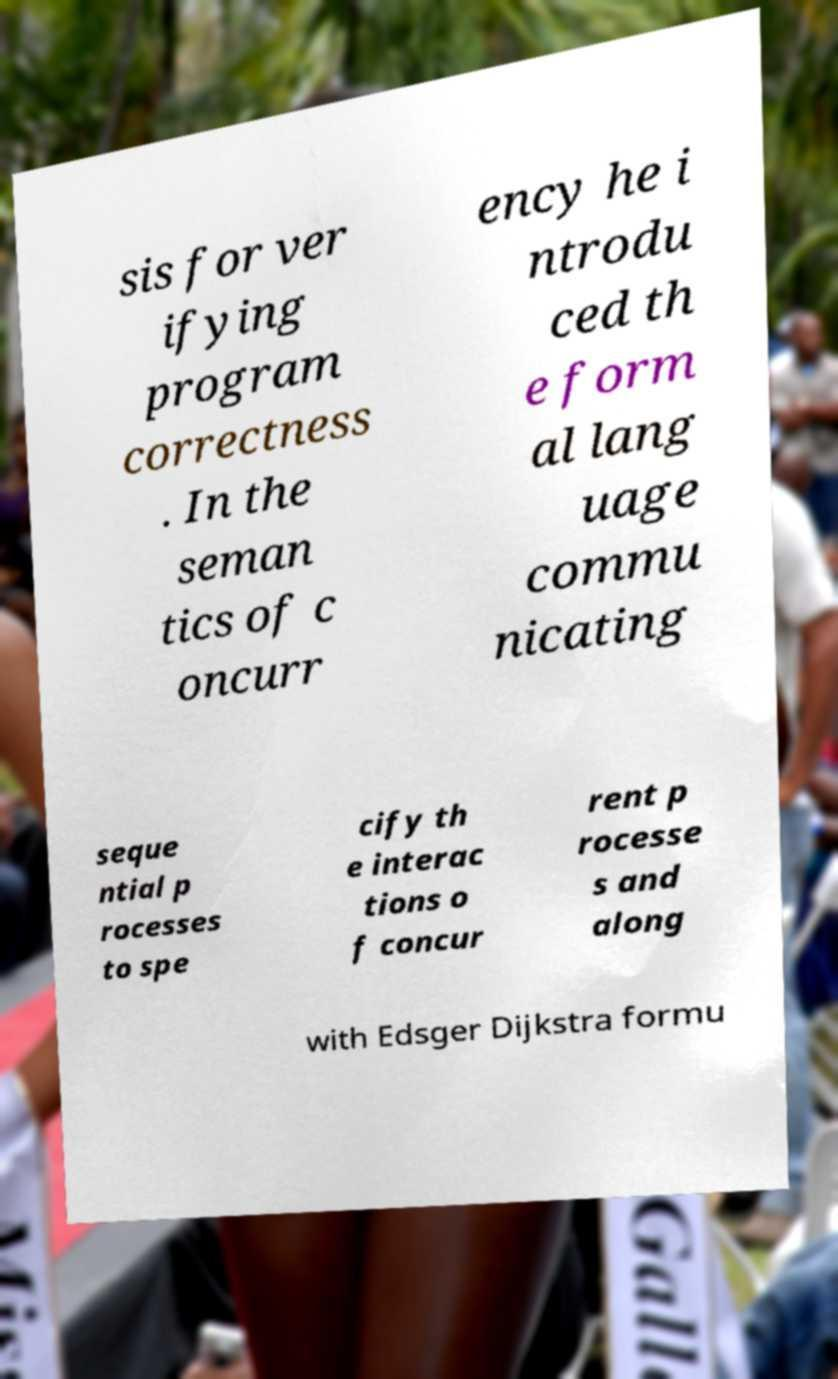Please identify and transcribe the text found in this image. sis for ver ifying program correctness . In the seman tics of c oncurr ency he i ntrodu ced th e form al lang uage commu nicating seque ntial p rocesses to spe cify th e interac tions o f concur rent p rocesse s and along with Edsger Dijkstra formu 